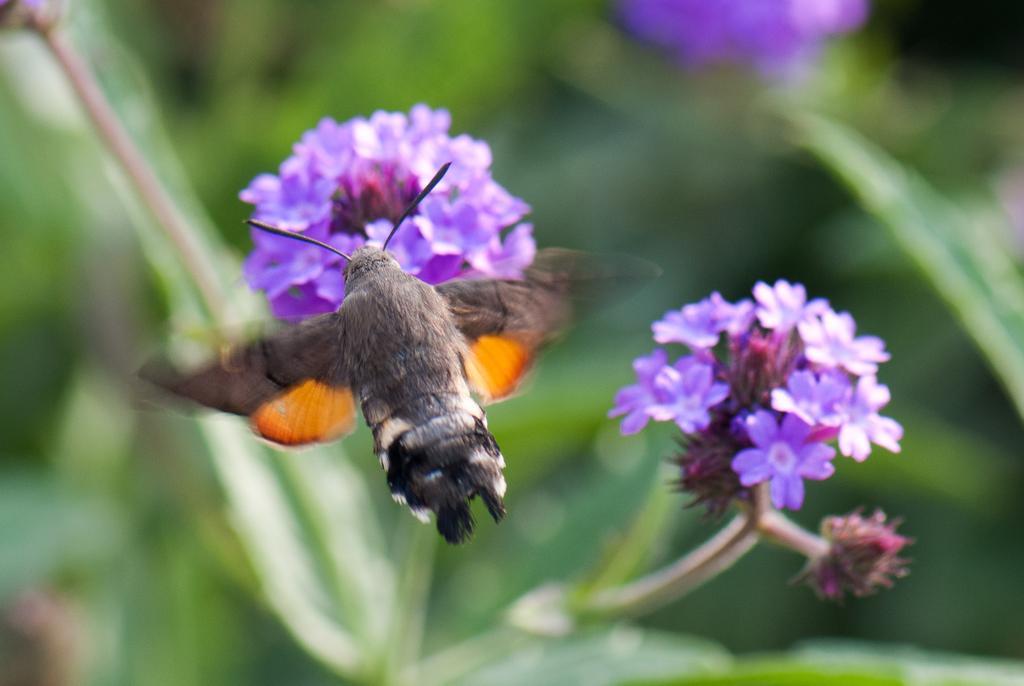In one or two sentences, can you explain what this image depicts? In this image there is like a honey bee and there are few flowers. The background is blurry. 